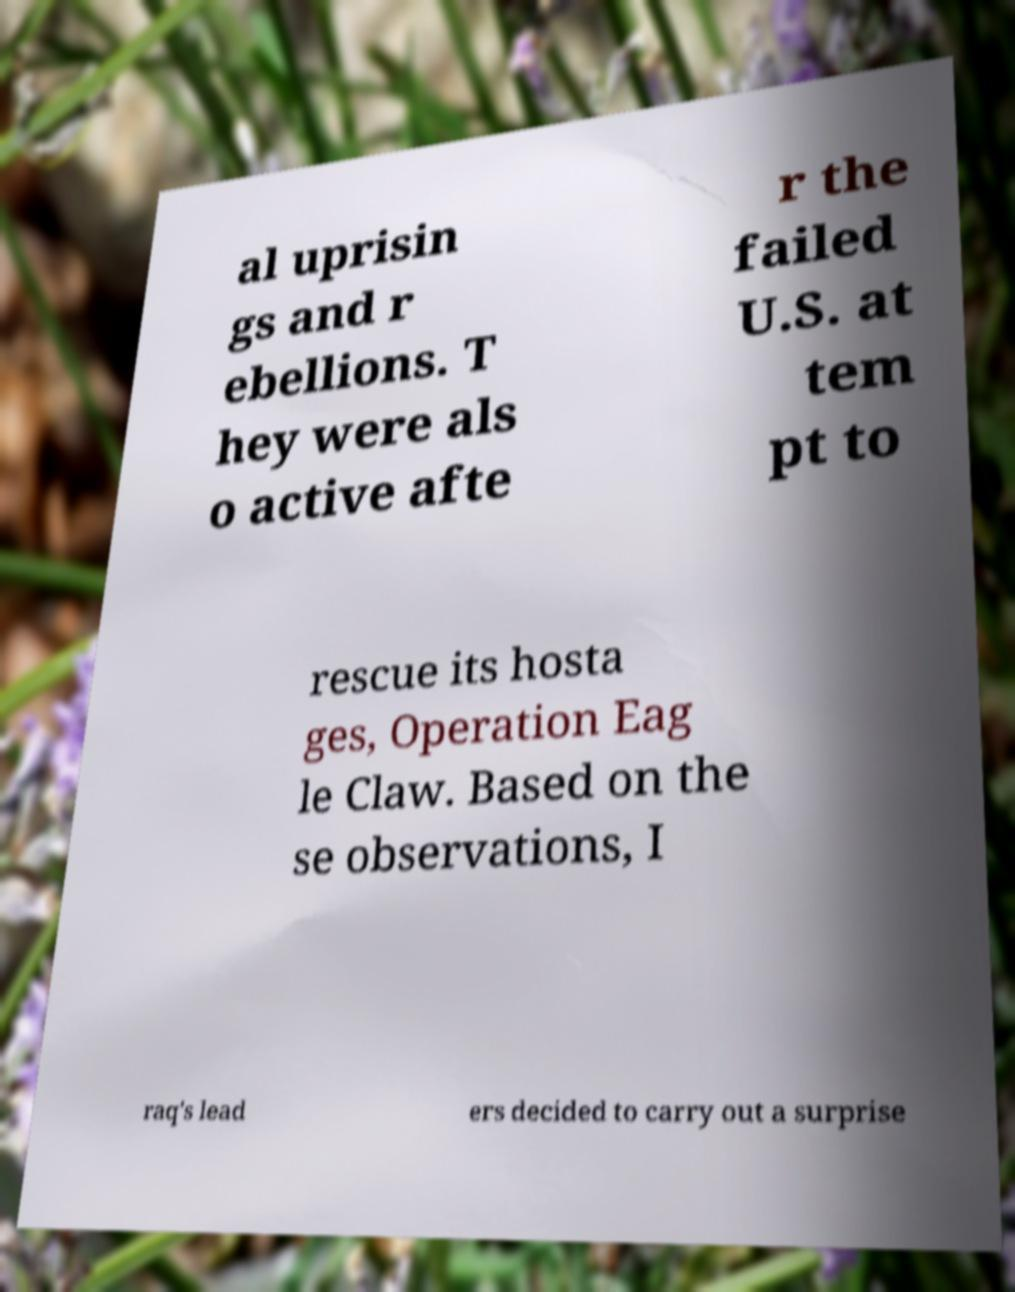I need the written content from this picture converted into text. Can you do that? al uprisin gs and r ebellions. T hey were als o active afte r the failed U.S. at tem pt to rescue its hosta ges, Operation Eag le Claw. Based on the se observations, I raq's lead ers decided to carry out a surprise 